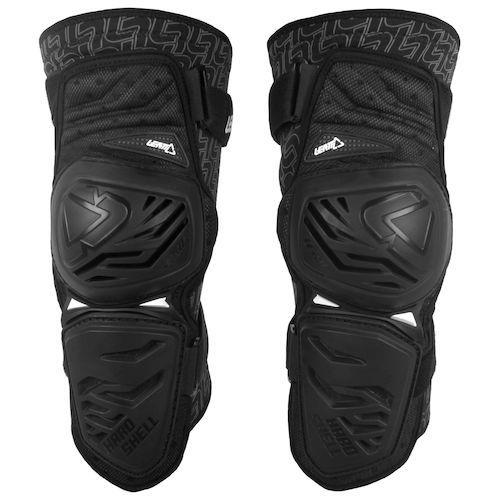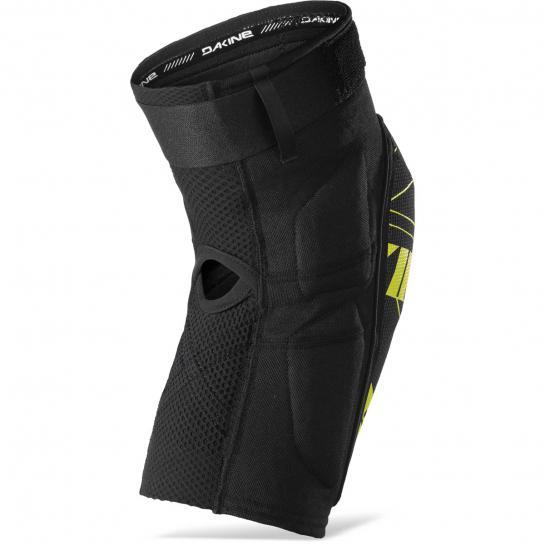The first image is the image on the left, the second image is the image on the right. Analyze the images presented: Is the assertion "there are full legged pants in the image pair" valid? Answer yes or no. No. 